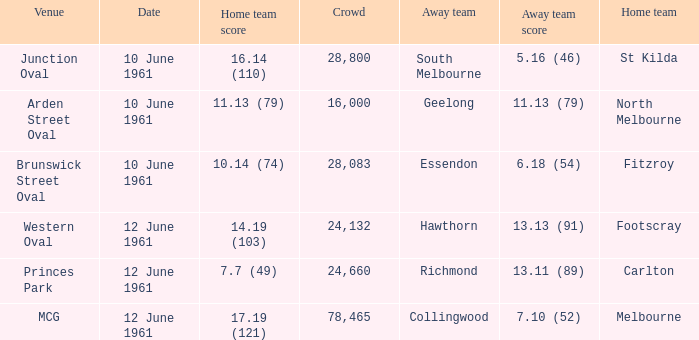Which venue has a crowd over 16,000 and a home team score of 7.7 (49)? Princes Park. 